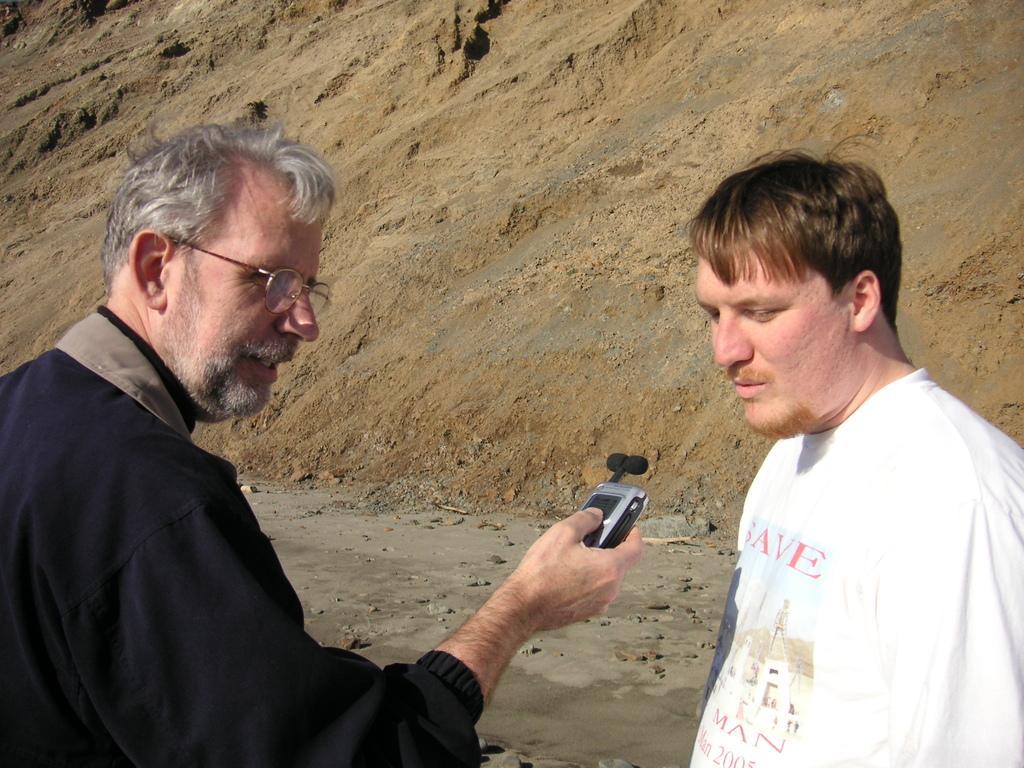Can you describe this image briefly? In this image we can see men standing on the ground and one of them is holding a machine in the hands. In the background there is a heap of sand. 